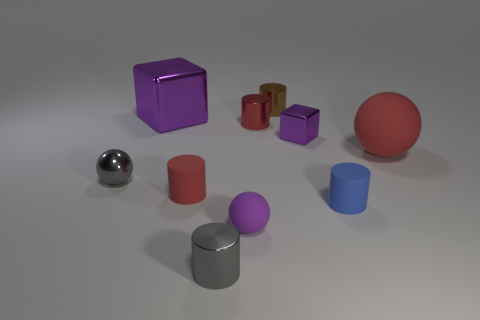Subtract all red metallic cylinders. How many cylinders are left? 4 Subtract all gray cylinders. How many cylinders are left? 4 Subtract all purple cylinders. Subtract all green balls. How many cylinders are left? 5 Subtract all balls. How many objects are left? 7 Add 7 brown cylinders. How many brown cylinders exist? 8 Subtract 0 blue spheres. How many objects are left? 10 Subtract all small gray metal balls. Subtract all red rubber objects. How many objects are left? 7 Add 1 tiny red matte cylinders. How many tiny red matte cylinders are left? 2 